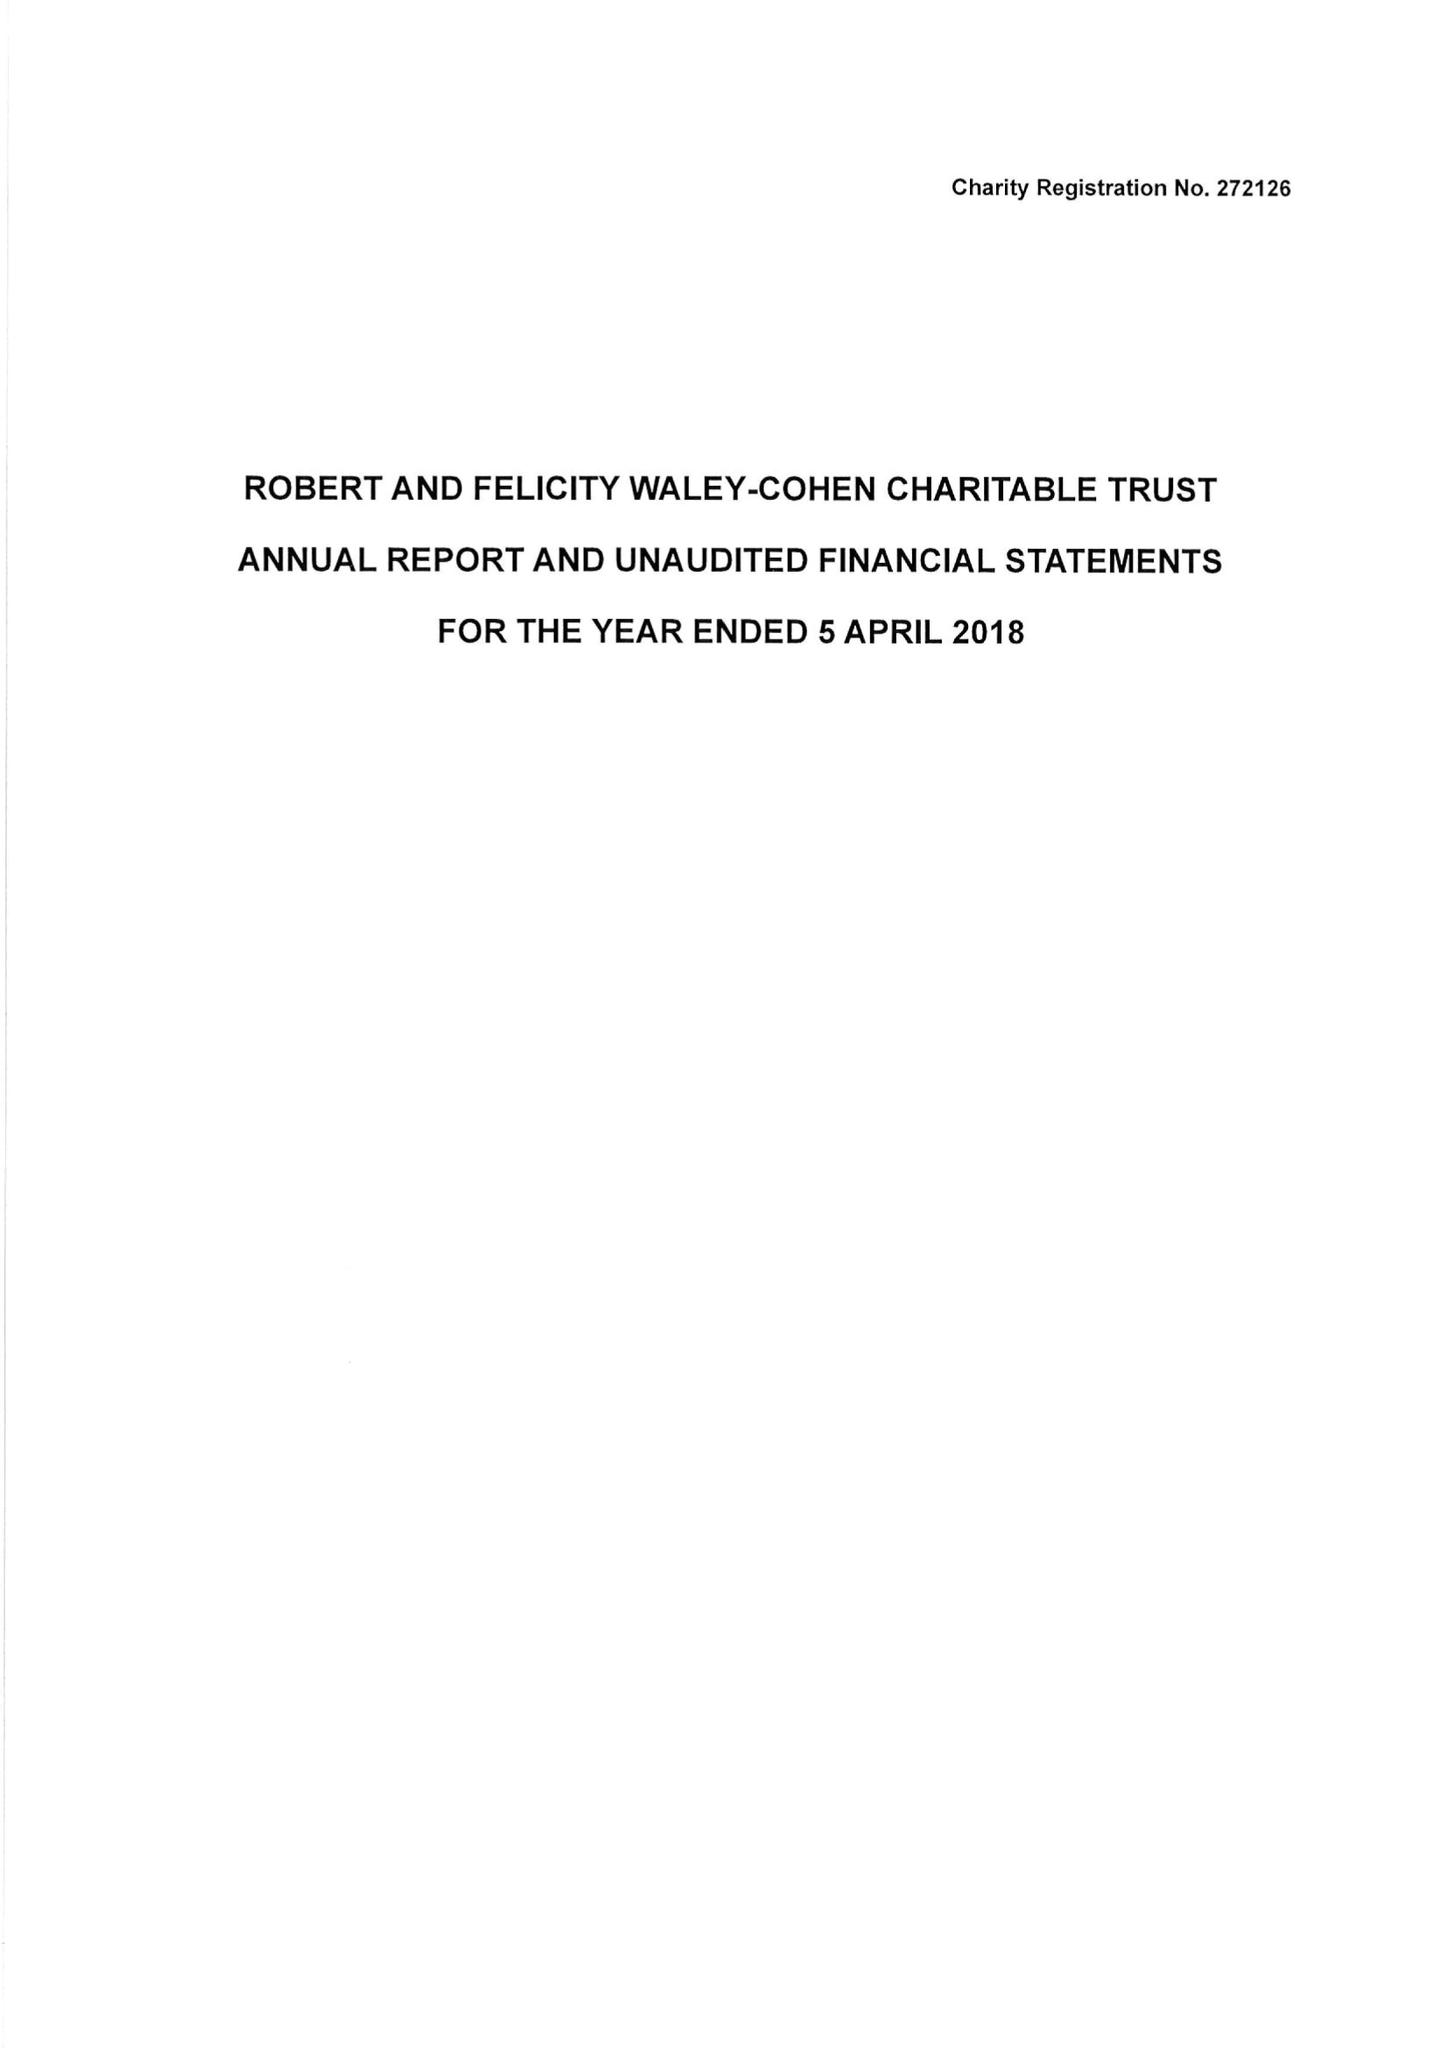What is the value for the spending_annually_in_british_pounds?
Answer the question using a single word or phrase. 231199.00 